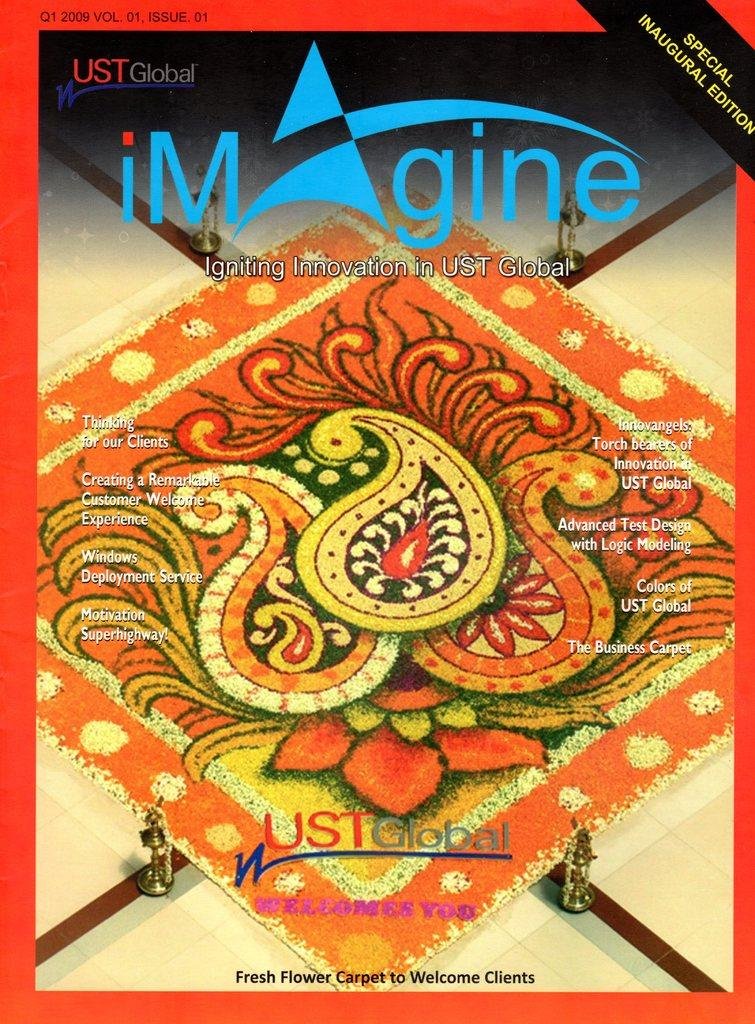<image>
Share a concise interpretation of the image provided. A magazine cover titled Imagine  with a picture of fresh flower carpet to welcome clients. 